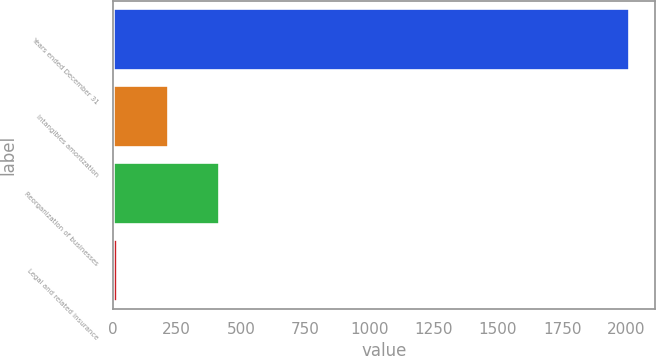Convert chart. <chart><loc_0><loc_0><loc_500><loc_500><bar_chart><fcel>Years ended December 31<fcel>Intangibles amortization<fcel>Reorganization of businesses<fcel>Legal and related insurance<nl><fcel>2012<fcel>215.6<fcel>415.2<fcel>16<nl></chart> 